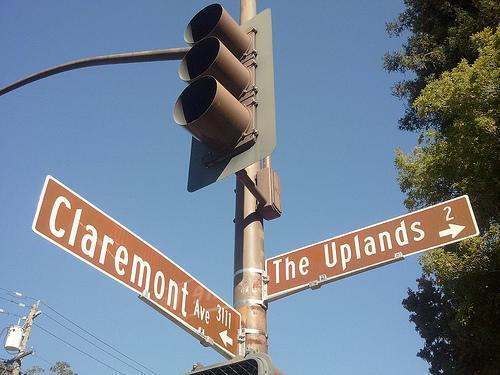How many people are in the image?
Give a very brief answer. 0. How many streetlights are on the pole?
Give a very brief answer. 3. 